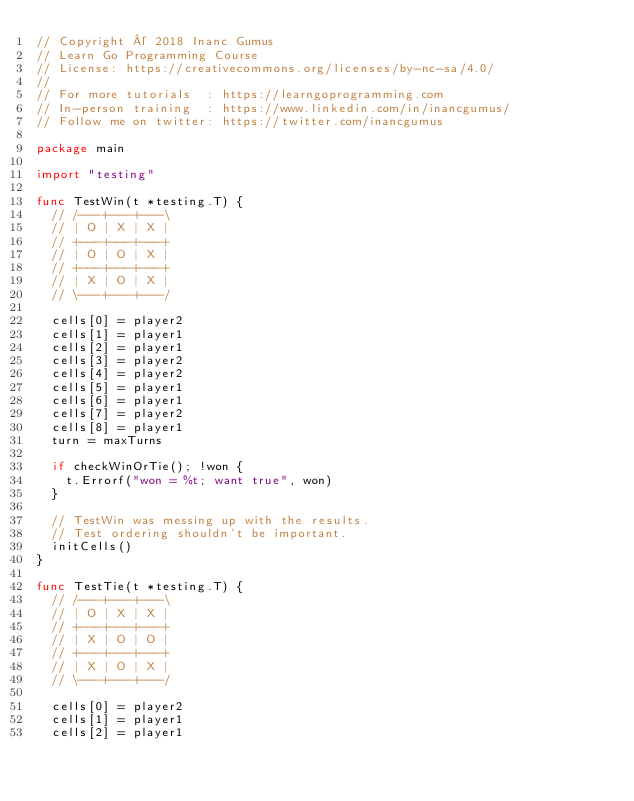Convert code to text. <code><loc_0><loc_0><loc_500><loc_500><_Go_>// Copyright © 2018 Inanc Gumus
// Learn Go Programming Course
// License: https://creativecommons.org/licenses/by-nc-sa/4.0/
//
// For more tutorials  : https://learngoprogramming.com
// In-person training  : https://www.linkedin.com/in/inancgumus/
// Follow me on twitter: https://twitter.com/inancgumus

package main

import "testing"

func TestWin(t *testing.T) {
	// /---+---+---\
	// | O | X | X |
	// +---+---+---+
	// | O | O | X |
	// +---+---+---+
	// | X | O | X |
	// \---+---+---/

	cells[0] = player2
	cells[1] = player1
	cells[2] = player1
	cells[3] = player2
	cells[4] = player2
	cells[5] = player1
	cells[6] = player1
	cells[7] = player2
	cells[8] = player1
	turn = maxTurns

	if checkWinOrTie(); !won {
		t.Errorf("won = %t; want true", won)
	}

	// TestWin was messing up with the results.
	// Test ordering shouldn't be important.
	initCells()
}

func TestTie(t *testing.T) {
	// /---+---+---\
	// | O | X | X |
	// +---+---+---+
	// | X | O | O |
	// +---+---+---+
	// | X | O | X |
	// \---+---+---/

	cells[0] = player2
	cells[1] = player1
	cells[2] = player1</code> 